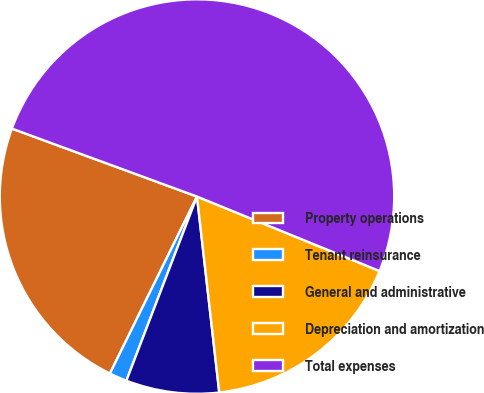Convert chart. <chart><loc_0><loc_0><loc_500><loc_500><pie_chart><fcel>Property operations<fcel>Tenant reinsurance<fcel>General and administrative<fcel>Depreciation and amortization<fcel>Total expenses<nl><fcel>23.32%<fcel>1.45%<fcel>7.63%<fcel>17.03%<fcel>50.56%<nl></chart> 